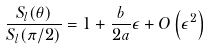Convert formula to latex. <formula><loc_0><loc_0><loc_500><loc_500>\frac { S _ { l } ( \theta ) } { S _ { l } ( \pi / 2 ) } = 1 + \frac { b } { 2 a } \epsilon + O \left ( \epsilon ^ { 2 } \right )</formula> 